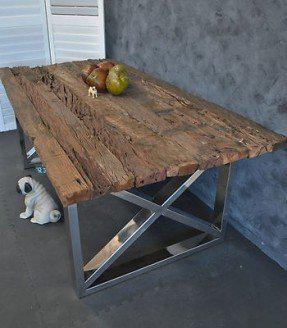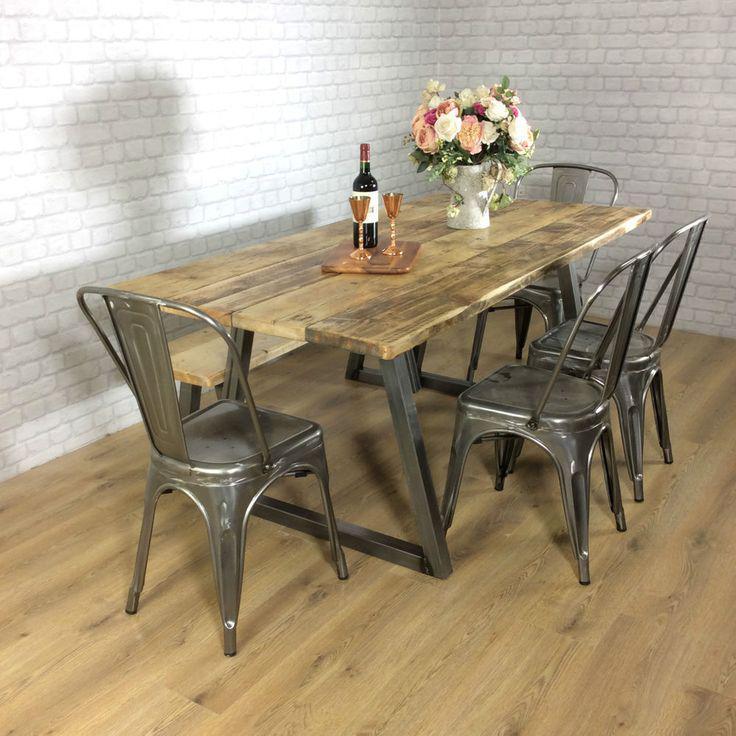The first image is the image on the left, the second image is the image on the right. Analyze the images presented: Is the assertion "There is a vase with flowers in the image on the left." valid? Answer yes or no. No. 